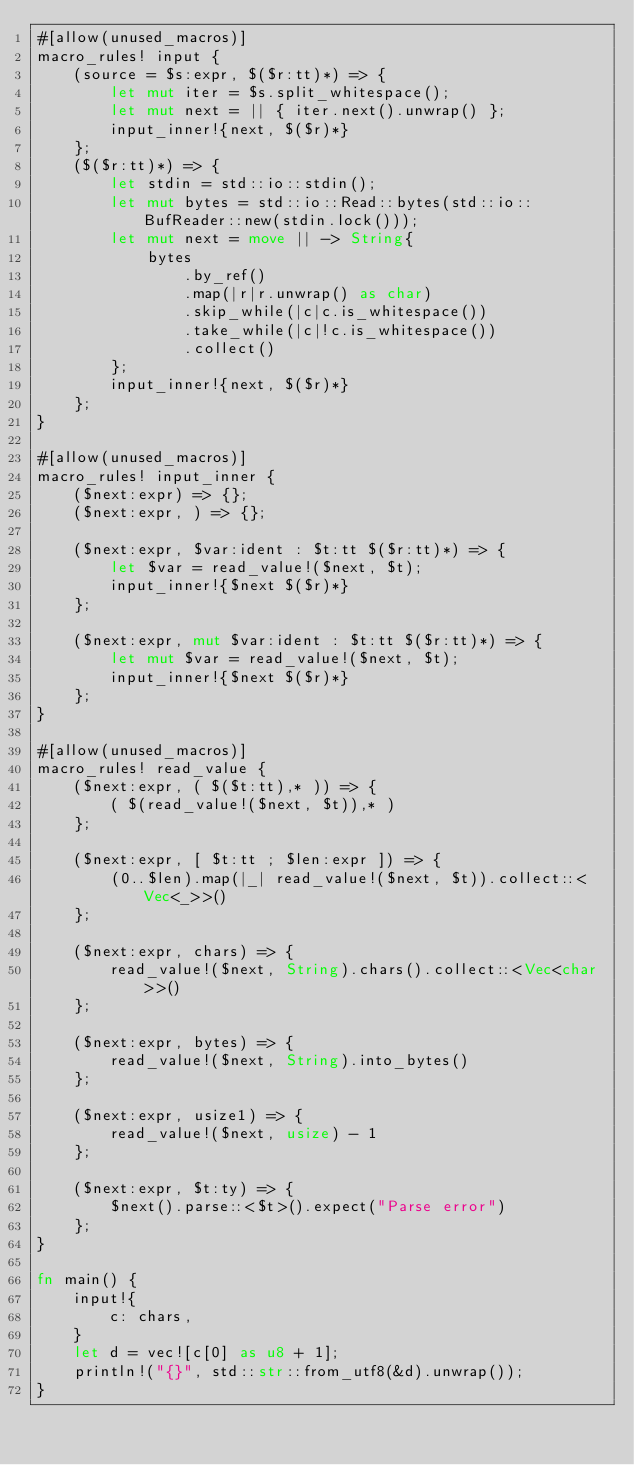<code> <loc_0><loc_0><loc_500><loc_500><_Rust_>#[allow(unused_macros)]
macro_rules! input {
    (source = $s:expr, $($r:tt)*) => {
        let mut iter = $s.split_whitespace();
        let mut next = || { iter.next().unwrap() };
        input_inner!{next, $($r)*}
    };
    ($($r:tt)*) => {
        let stdin = std::io::stdin();
        let mut bytes = std::io::Read::bytes(std::io::BufReader::new(stdin.lock()));
        let mut next = move || -> String{
            bytes
                .by_ref()
                .map(|r|r.unwrap() as char)
                .skip_while(|c|c.is_whitespace())
                .take_while(|c|!c.is_whitespace())
                .collect()
        };
        input_inner!{next, $($r)*}
    };
}

#[allow(unused_macros)]
macro_rules! input_inner {
    ($next:expr) => {};
    ($next:expr, ) => {};

    ($next:expr, $var:ident : $t:tt $($r:tt)*) => {
        let $var = read_value!($next, $t);
        input_inner!{$next $($r)*}
    };

    ($next:expr, mut $var:ident : $t:tt $($r:tt)*) => {
        let mut $var = read_value!($next, $t);
        input_inner!{$next $($r)*}
    };
}

#[allow(unused_macros)]
macro_rules! read_value {
    ($next:expr, ( $($t:tt),* )) => {
        ( $(read_value!($next, $t)),* )
    };

    ($next:expr, [ $t:tt ; $len:expr ]) => {
        (0..$len).map(|_| read_value!($next, $t)).collect::<Vec<_>>()
    };

    ($next:expr, chars) => {
        read_value!($next, String).chars().collect::<Vec<char>>()
    };

    ($next:expr, bytes) => {
        read_value!($next, String).into_bytes()
    };

    ($next:expr, usize1) => {
        read_value!($next, usize) - 1
    };

    ($next:expr, $t:ty) => {
        $next().parse::<$t>().expect("Parse error")
    };
}

fn main() {
    input!{
        c: chars,
    }
    let d = vec![c[0] as u8 + 1];
    println!("{}", std::str::from_utf8(&d).unwrap());
}</code> 